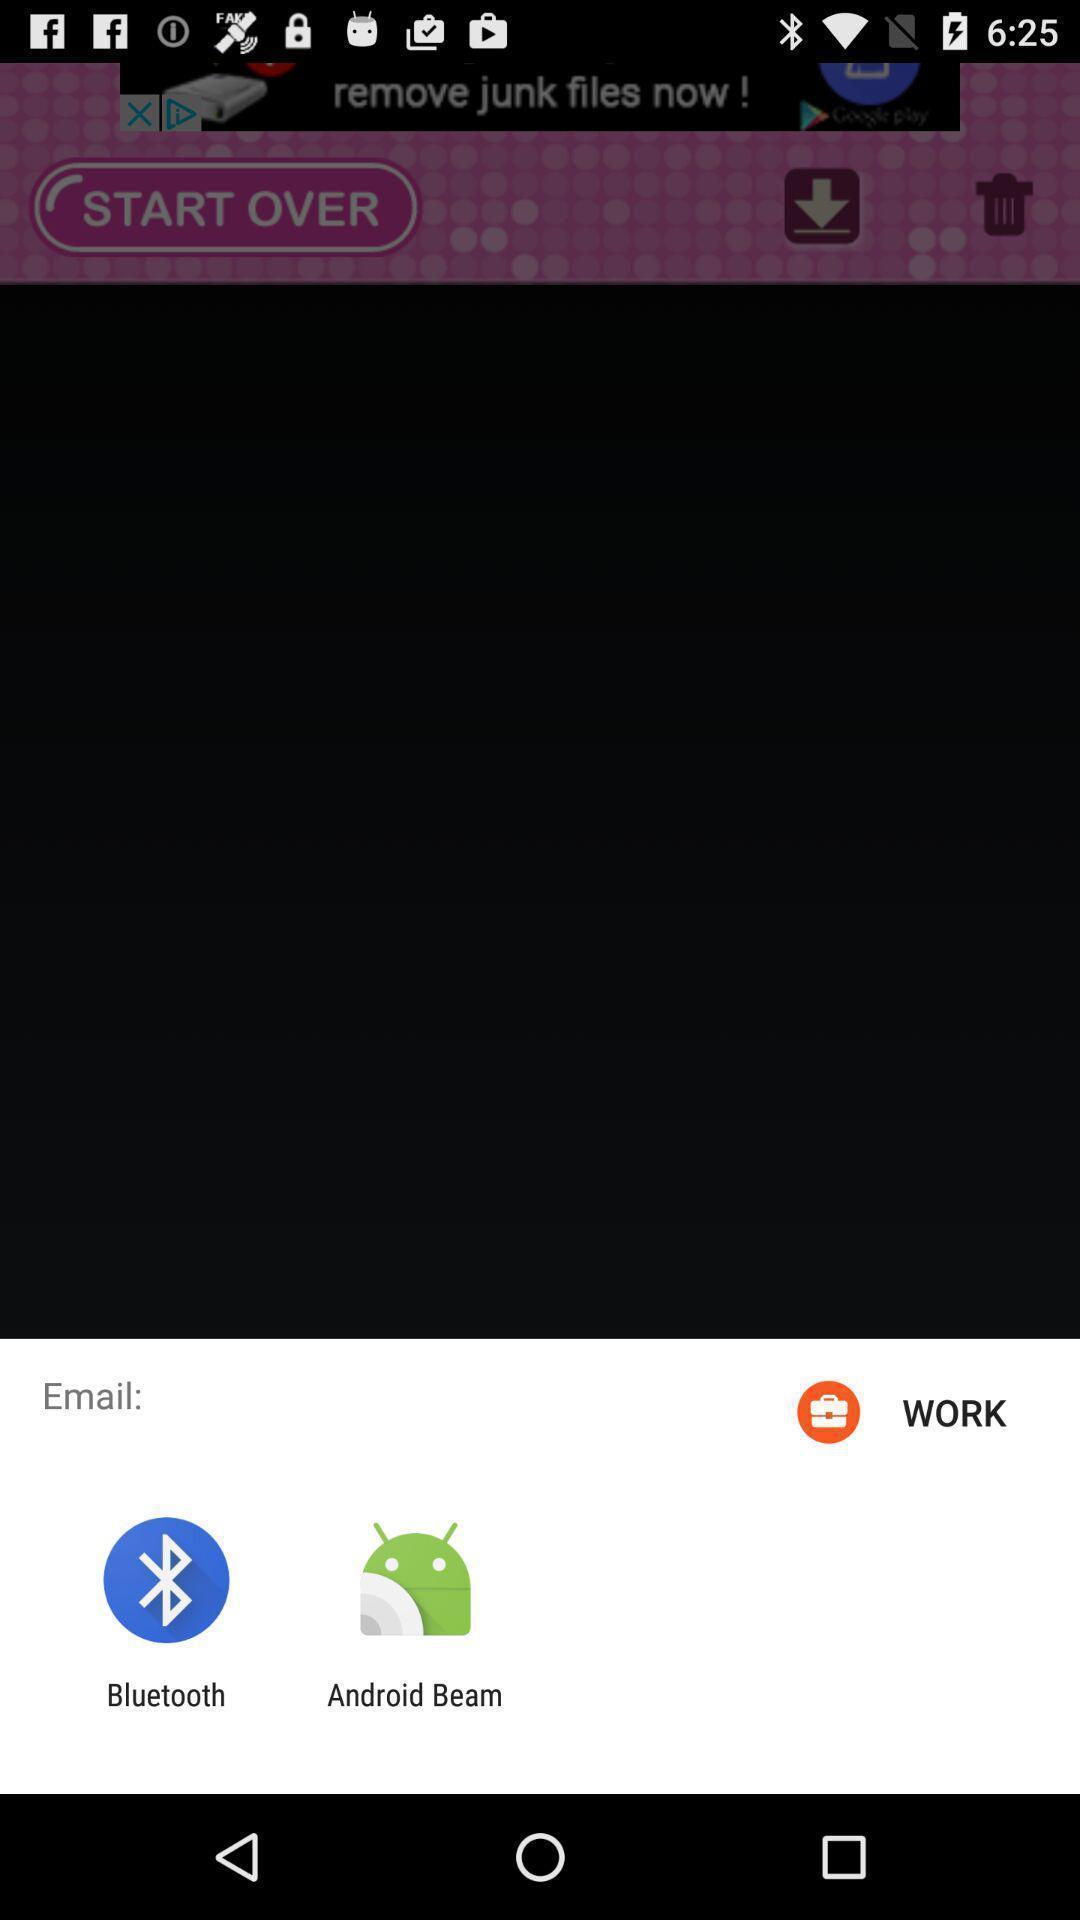Please provide a description for this image. Window displaying an app to share via email. 